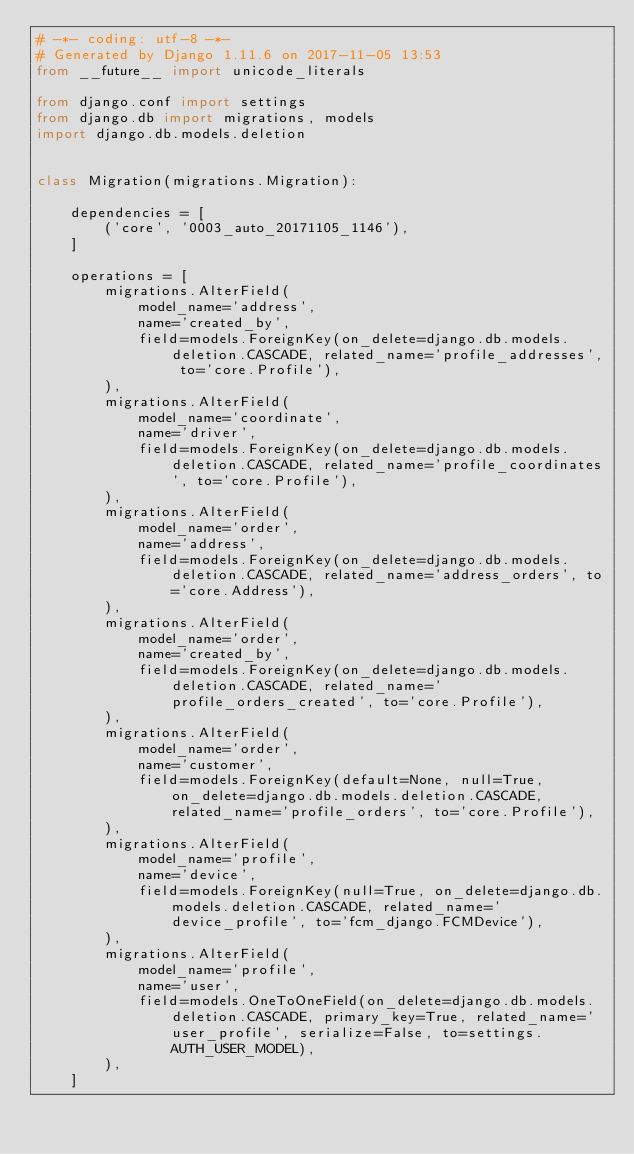<code> <loc_0><loc_0><loc_500><loc_500><_Python_># -*- coding: utf-8 -*-
# Generated by Django 1.11.6 on 2017-11-05 13:53
from __future__ import unicode_literals

from django.conf import settings
from django.db import migrations, models
import django.db.models.deletion


class Migration(migrations.Migration):

    dependencies = [
        ('core', '0003_auto_20171105_1146'),
    ]

    operations = [
        migrations.AlterField(
            model_name='address',
            name='created_by',
            field=models.ForeignKey(on_delete=django.db.models.deletion.CASCADE, related_name='profile_addresses', to='core.Profile'),
        ),
        migrations.AlterField(
            model_name='coordinate',
            name='driver',
            field=models.ForeignKey(on_delete=django.db.models.deletion.CASCADE, related_name='profile_coordinates', to='core.Profile'),
        ),
        migrations.AlterField(
            model_name='order',
            name='address',
            field=models.ForeignKey(on_delete=django.db.models.deletion.CASCADE, related_name='address_orders', to='core.Address'),
        ),
        migrations.AlterField(
            model_name='order',
            name='created_by',
            field=models.ForeignKey(on_delete=django.db.models.deletion.CASCADE, related_name='profile_orders_created', to='core.Profile'),
        ),
        migrations.AlterField(
            model_name='order',
            name='customer',
            field=models.ForeignKey(default=None, null=True, on_delete=django.db.models.deletion.CASCADE, related_name='profile_orders', to='core.Profile'),
        ),
        migrations.AlterField(
            model_name='profile',
            name='device',
            field=models.ForeignKey(null=True, on_delete=django.db.models.deletion.CASCADE, related_name='device_profile', to='fcm_django.FCMDevice'),
        ),
        migrations.AlterField(
            model_name='profile',
            name='user',
            field=models.OneToOneField(on_delete=django.db.models.deletion.CASCADE, primary_key=True, related_name='user_profile', serialize=False, to=settings.AUTH_USER_MODEL),
        ),
    ]
</code> 